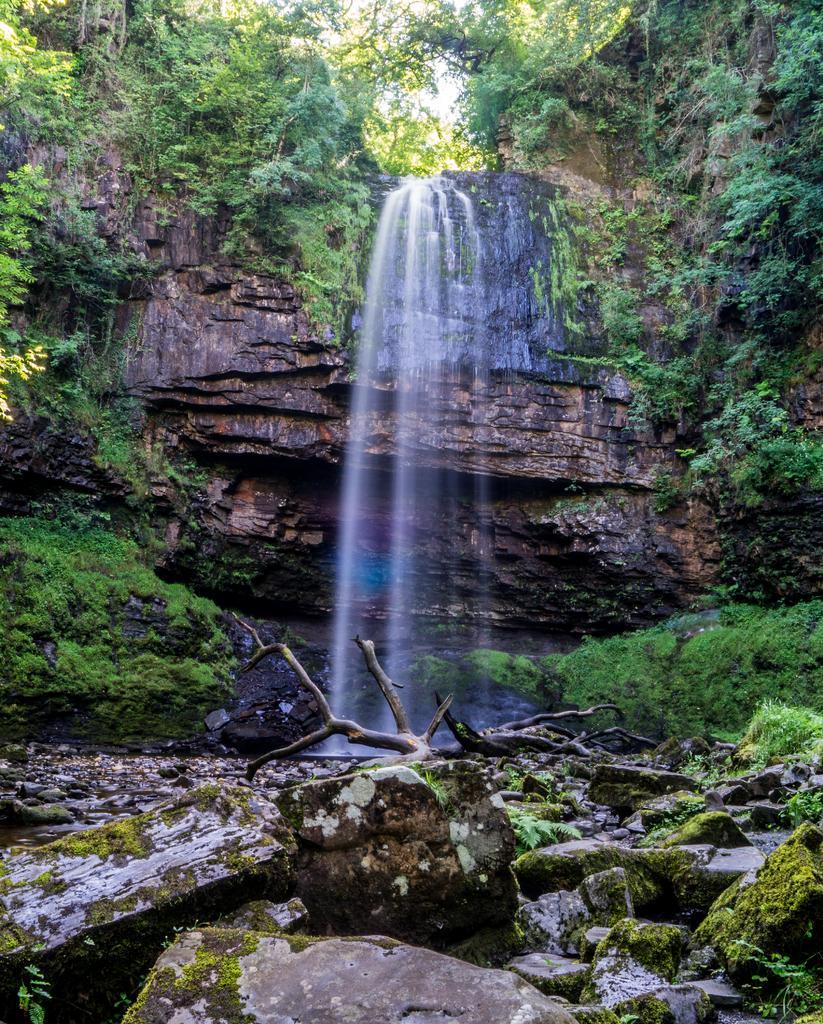In one or two sentences, can you explain what this image depicts? In this image in the center there is a water fall, and on the right side and left side there are some plants, trees and some rocks. 